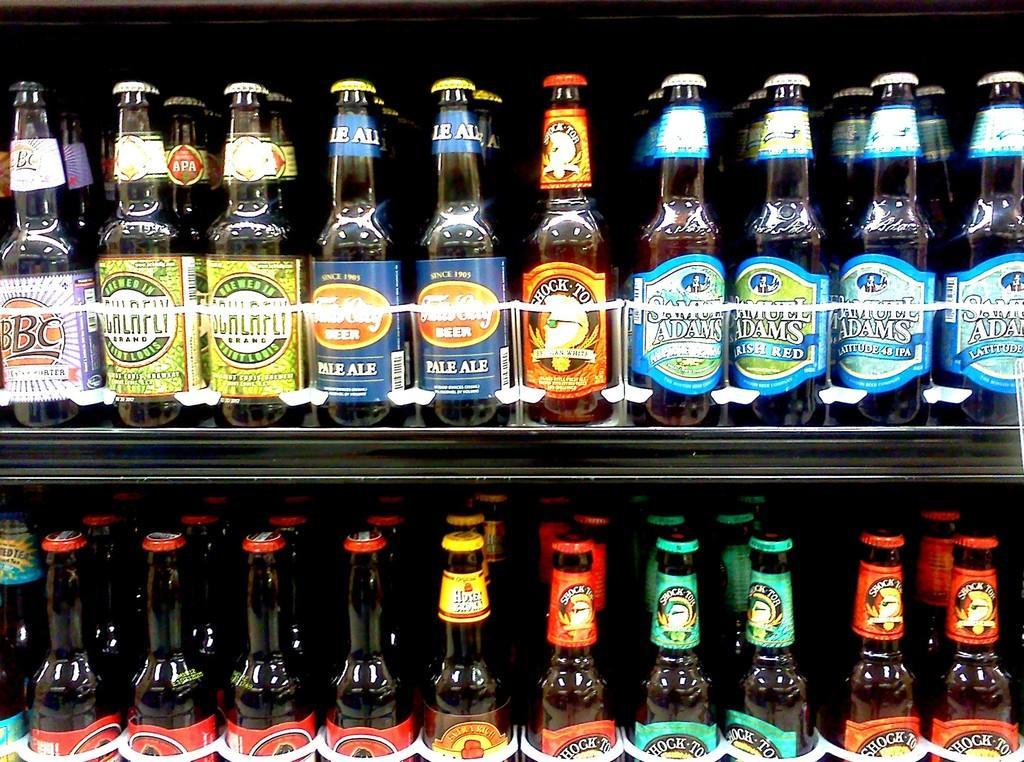In one or two sentences, can you explain what this image depicts? In this picture we can see couple of bottles in the rack. 